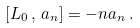Convert formula to latex. <formula><loc_0><loc_0><loc_500><loc_500>[ L _ { 0 } \, , \, a _ { n } ] = - n a _ { n } \, .</formula> 